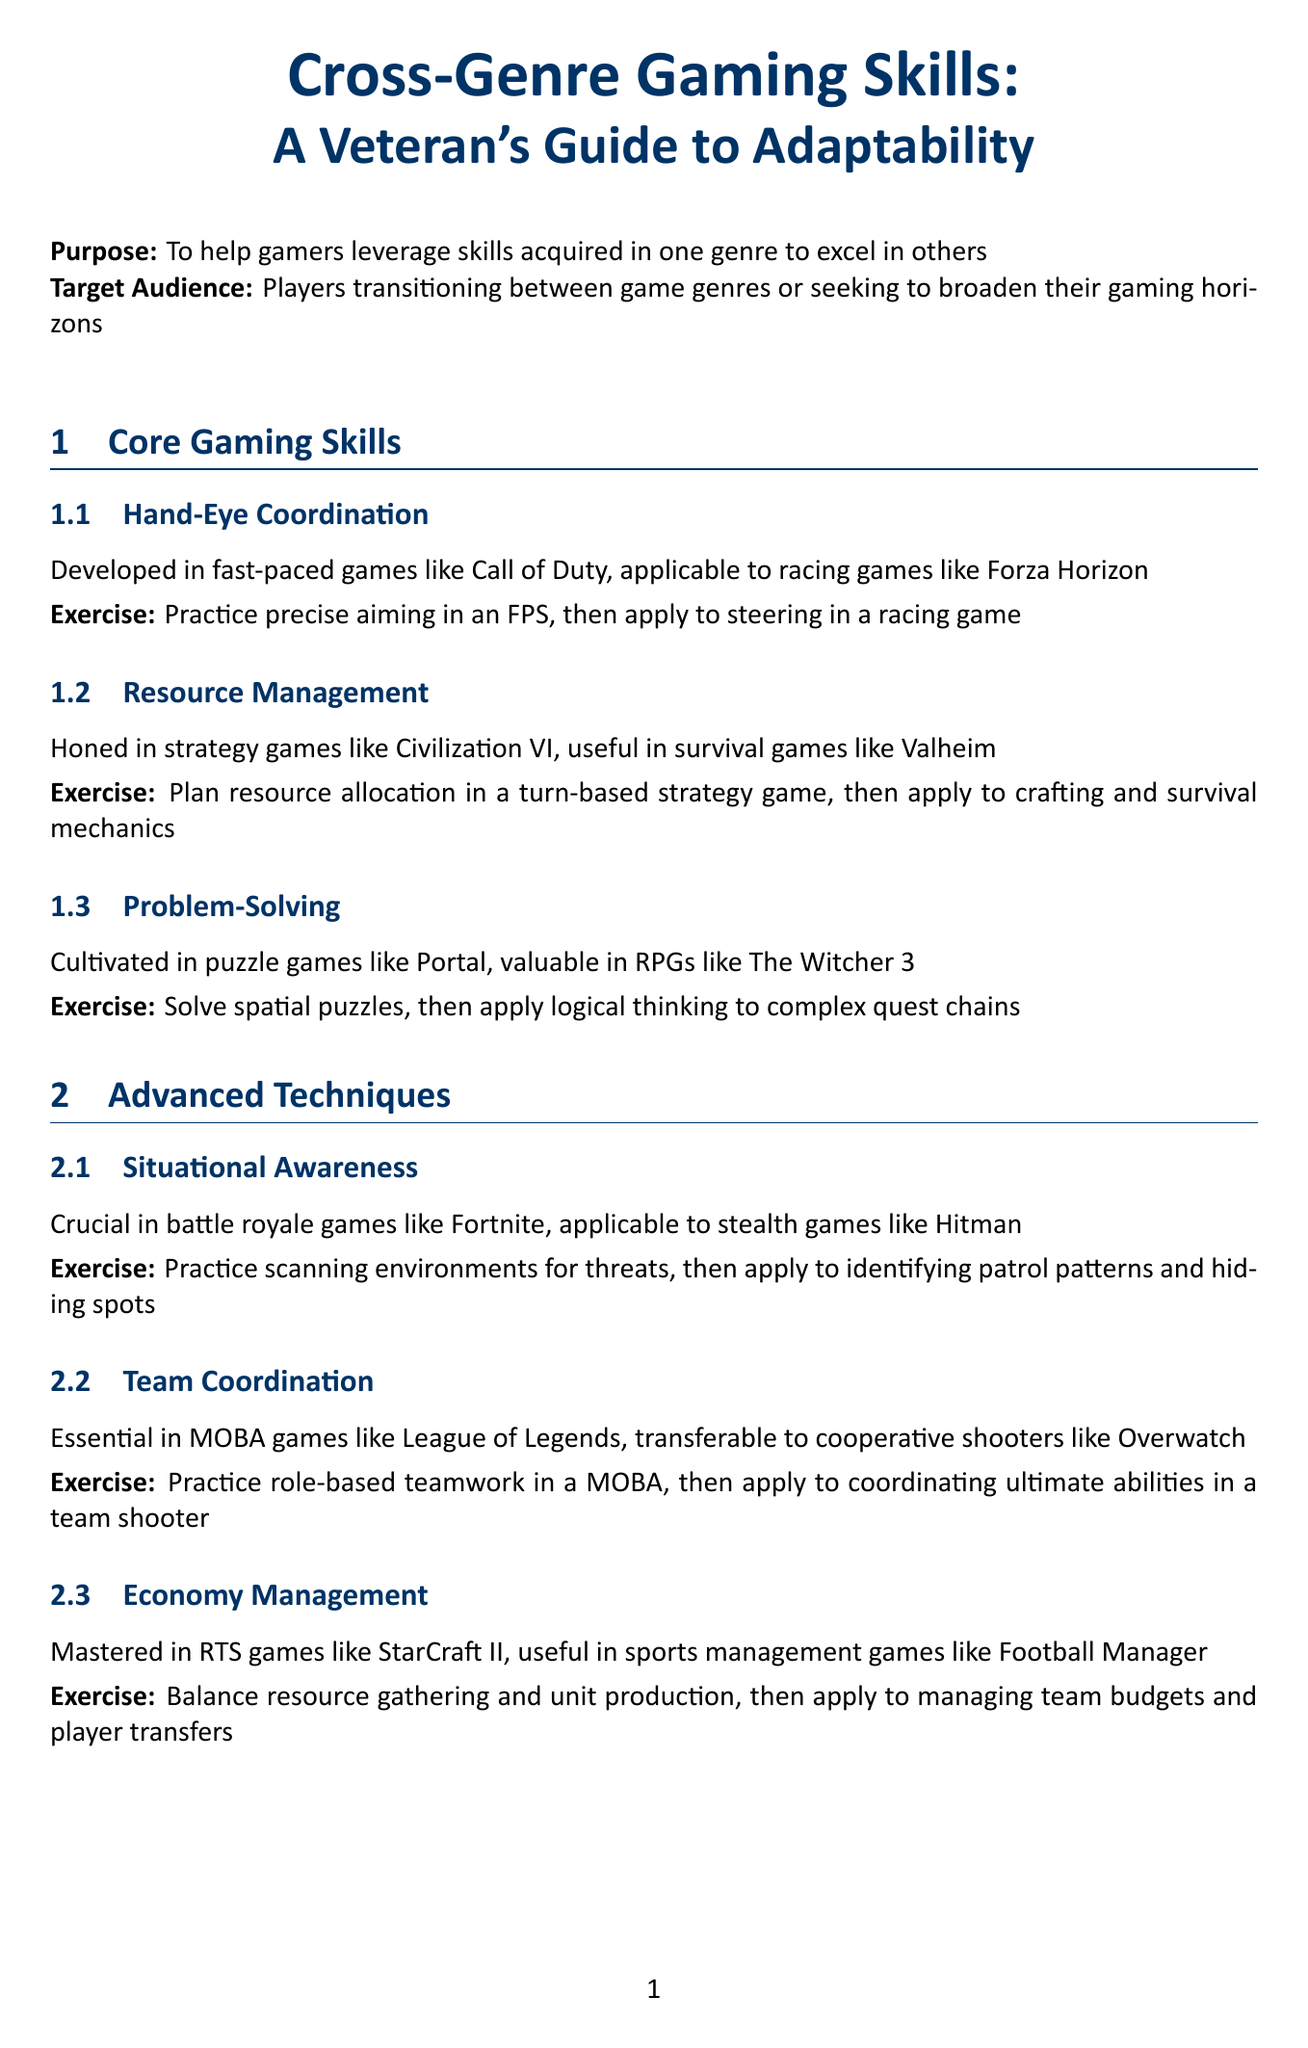What is the title of the manual? The title is explicitly stated at the beginning of the document as "Cross-Genre Gaming Skills: A Veteran's Guide to Adaptability".
Answer: Cross-Genre Gaming Skills: A Veteran's Guide to Adaptability Who is the target audience of the manual? The target audience is specified in the introduction section, indicating who the manual is meant for.
Answer: Players transitioning between game genres or seeking to broaden their gaming horizons How many subsections are there under Core Gaming Skills? The document lists three subsections specifically under the Core Gaming Skills section.
Answer: 3 Which game is mentioned in connection with Resource Management? The document specifies Civilization VI as the game for honing resource management skills.
Answer: Civilization VI What type of exercise is suggested for Situational Awareness? The manual provides a specific exercise related to situational awareness based on practice in both Fortnite and Hitman.
Answer: Practice scanning environments for threats, then apply to identifying patrol patterns and hiding spots What psychological aspect is associated with Dark Souls? The document relates Stress Management as a psychological aspect developed in high-pressure games like Dark Souls.
Answer: Stress Management How many appendices are included in the document? The appendices are labeled with letters and a total of three are included.
Answer: 3 What skill is honed in roguelike games like Hades? Adaptability is the skill mentioned in the context of roguelike games like Hades.
Answer: Adaptability 